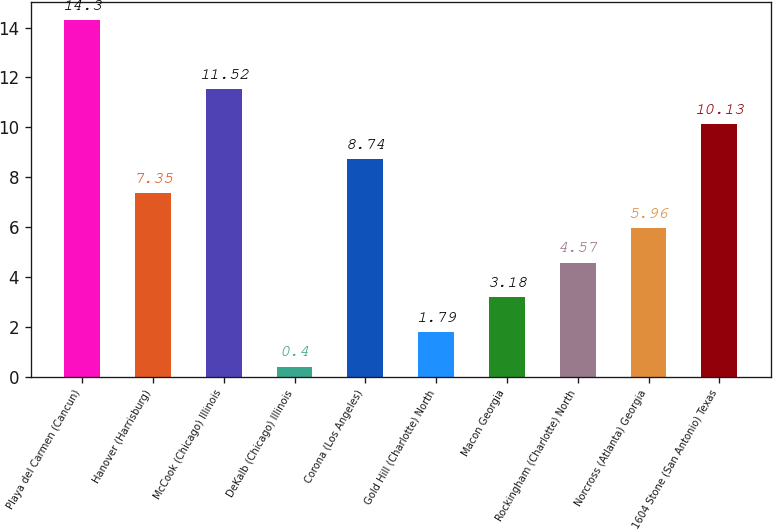Convert chart to OTSL. <chart><loc_0><loc_0><loc_500><loc_500><bar_chart><fcel>Playa del Carmen (Cancun)<fcel>Hanover (Harrisburg)<fcel>McCook (Chicago) Illinois<fcel>DeKalb (Chicago) Illinois<fcel>Corona (Los Angeles)<fcel>Gold Hill (Charlotte) North<fcel>Macon Georgia<fcel>Rockingham (Charlotte) North<fcel>Norcross (Atlanta) Georgia<fcel>1604 Stone (San Antonio) Texas<nl><fcel>14.3<fcel>7.35<fcel>11.52<fcel>0.4<fcel>8.74<fcel>1.79<fcel>3.18<fcel>4.57<fcel>5.96<fcel>10.13<nl></chart> 